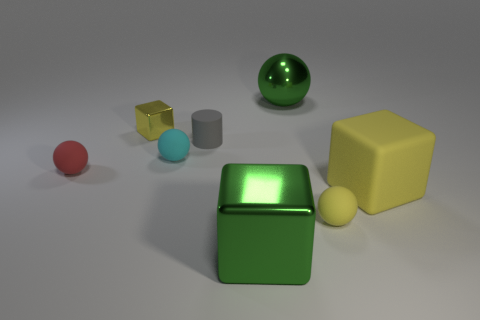How many big things are purple spheres or red rubber objects?
Give a very brief answer. 0. How many other things are there of the same color as the big sphere?
Keep it short and to the point. 1. How many large green blocks are the same material as the big green ball?
Make the answer very short. 1. There is a metal block behind the yellow matte sphere; is its color the same as the matte block?
Your response must be concise. Yes. How many blue objects are either large cubes or tiny cubes?
Offer a very short reply. 0. Is there any other thing that has the same material as the small gray cylinder?
Provide a succinct answer. Yes. Do the tiny yellow thing left of the gray matte thing and the cylinder have the same material?
Ensure brevity in your answer.  No. What number of objects are tiny rubber things or small objects on the right side of the red matte object?
Ensure brevity in your answer.  5. There is a large green object that is right of the green metal object left of the large metallic ball; what number of large green spheres are to the right of it?
Make the answer very short. 0. Is the shape of the green shiny object behind the small cyan matte thing the same as  the large yellow object?
Offer a terse response. No. 